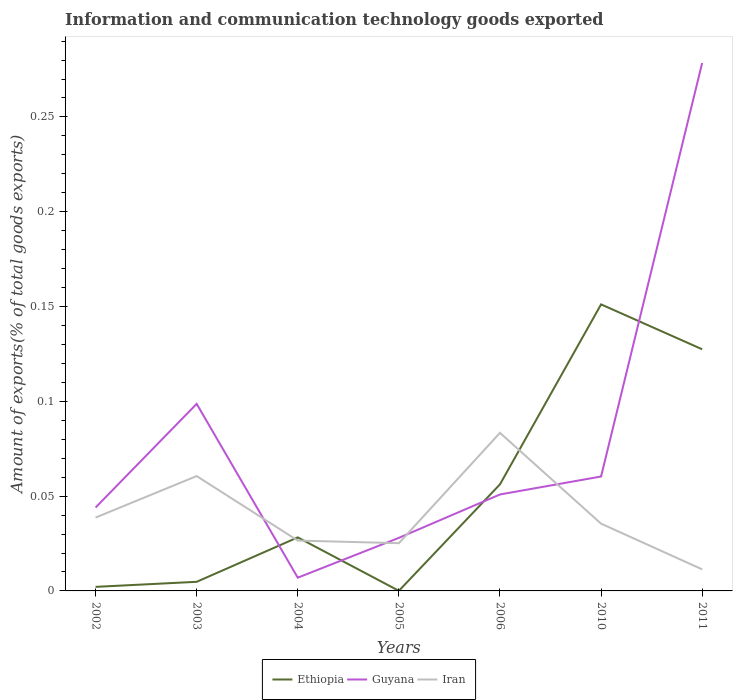Across all years, what is the maximum amount of goods exported in Iran?
Provide a short and direct response. 0.01. In which year was the amount of goods exported in Guyana maximum?
Provide a short and direct response. 2004. What is the total amount of goods exported in Guyana in the graph?
Ensure brevity in your answer.  -0.01. What is the difference between the highest and the second highest amount of goods exported in Ethiopia?
Give a very brief answer. 0.15. What is the difference between the highest and the lowest amount of goods exported in Iran?
Offer a very short reply. 2. Is the amount of goods exported in Ethiopia strictly greater than the amount of goods exported in Iran over the years?
Give a very brief answer. No. How many lines are there?
Offer a very short reply. 3. Does the graph contain any zero values?
Your response must be concise. No. Does the graph contain grids?
Your answer should be very brief. No. How are the legend labels stacked?
Ensure brevity in your answer.  Horizontal. What is the title of the graph?
Give a very brief answer. Information and communication technology goods exported. What is the label or title of the X-axis?
Make the answer very short. Years. What is the label or title of the Y-axis?
Provide a succinct answer. Amount of exports(% of total goods exports). What is the Amount of exports(% of total goods exports) of Ethiopia in 2002?
Offer a very short reply. 0. What is the Amount of exports(% of total goods exports) in Guyana in 2002?
Your answer should be compact. 0.04. What is the Amount of exports(% of total goods exports) of Iran in 2002?
Provide a succinct answer. 0.04. What is the Amount of exports(% of total goods exports) of Ethiopia in 2003?
Your answer should be very brief. 0. What is the Amount of exports(% of total goods exports) in Guyana in 2003?
Ensure brevity in your answer.  0.1. What is the Amount of exports(% of total goods exports) in Iran in 2003?
Offer a terse response. 0.06. What is the Amount of exports(% of total goods exports) in Ethiopia in 2004?
Ensure brevity in your answer.  0.03. What is the Amount of exports(% of total goods exports) of Guyana in 2004?
Offer a terse response. 0.01. What is the Amount of exports(% of total goods exports) in Iran in 2004?
Keep it short and to the point. 0.03. What is the Amount of exports(% of total goods exports) of Ethiopia in 2005?
Keep it short and to the point. 5.79786e-5. What is the Amount of exports(% of total goods exports) of Guyana in 2005?
Your answer should be very brief. 0.03. What is the Amount of exports(% of total goods exports) of Iran in 2005?
Provide a succinct answer. 0.03. What is the Amount of exports(% of total goods exports) of Ethiopia in 2006?
Give a very brief answer. 0.06. What is the Amount of exports(% of total goods exports) of Guyana in 2006?
Your response must be concise. 0.05. What is the Amount of exports(% of total goods exports) in Iran in 2006?
Your answer should be very brief. 0.08. What is the Amount of exports(% of total goods exports) of Ethiopia in 2010?
Make the answer very short. 0.15. What is the Amount of exports(% of total goods exports) of Guyana in 2010?
Provide a short and direct response. 0.06. What is the Amount of exports(% of total goods exports) of Iran in 2010?
Keep it short and to the point. 0.04. What is the Amount of exports(% of total goods exports) of Ethiopia in 2011?
Offer a very short reply. 0.13. What is the Amount of exports(% of total goods exports) in Guyana in 2011?
Keep it short and to the point. 0.28. What is the Amount of exports(% of total goods exports) in Iran in 2011?
Provide a succinct answer. 0.01. Across all years, what is the maximum Amount of exports(% of total goods exports) of Ethiopia?
Offer a terse response. 0.15. Across all years, what is the maximum Amount of exports(% of total goods exports) in Guyana?
Provide a succinct answer. 0.28. Across all years, what is the maximum Amount of exports(% of total goods exports) of Iran?
Your answer should be compact. 0.08. Across all years, what is the minimum Amount of exports(% of total goods exports) of Ethiopia?
Offer a very short reply. 5.79786e-5. Across all years, what is the minimum Amount of exports(% of total goods exports) of Guyana?
Provide a short and direct response. 0.01. Across all years, what is the minimum Amount of exports(% of total goods exports) in Iran?
Offer a very short reply. 0.01. What is the total Amount of exports(% of total goods exports) of Ethiopia in the graph?
Your answer should be compact. 0.37. What is the total Amount of exports(% of total goods exports) in Guyana in the graph?
Offer a very short reply. 0.57. What is the total Amount of exports(% of total goods exports) of Iran in the graph?
Provide a succinct answer. 0.28. What is the difference between the Amount of exports(% of total goods exports) in Ethiopia in 2002 and that in 2003?
Your answer should be very brief. -0. What is the difference between the Amount of exports(% of total goods exports) in Guyana in 2002 and that in 2003?
Offer a terse response. -0.05. What is the difference between the Amount of exports(% of total goods exports) in Iran in 2002 and that in 2003?
Make the answer very short. -0.02. What is the difference between the Amount of exports(% of total goods exports) in Ethiopia in 2002 and that in 2004?
Provide a short and direct response. -0.03. What is the difference between the Amount of exports(% of total goods exports) in Guyana in 2002 and that in 2004?
Your response must be concise. 0.04. What is the difference between the Amount of exports(% of total goods exports) of Iran in 2002 and that in 2004?
Ensure brevity in your answer.  0.01. What is the difference between the Amount of exports(% of total goods exports) of Ethiopia in 2002 and that in 2005?
Offer a very short reply. 0. What is the difference between the Amount of exports(% of total goods exports) in Guyana in 2002 and that in 2005?
Provide a short and direct response. 0.02. What is the difference between the Amount of exports(% of total goods exports) in Iran in 2002 and that in 2005?
Ensure brevity in your answer.  0.01. What is the difference between the Amount of exports(% of total goods exports) in Ethiopia in 2002 and that in 2006?
Make the answer very short. -0.05. What is the difference between the Amount of exports(% of total goods exports) of Guyana in 2002 and that in 2006?
Make the answer very short. -0.01. What is the difference between the Amount of exports(% of total goods exports) of Iran in 2002 and that in 2006?
Keep it short and to the point. -0.04. What is the difference between the Amount of exports(% of total goods exports) in Ethiopia in 2002 and that in 2010?
Your response must be concise. -0.15. What is the difference between the Amount of exports(% of total goods exports) in Guyana in 2002 and that in 2010?
Provide a succinct answer. -0.02. What is the difference between the Amount of exports(% of total goods exports) in Iran in 2002 and that in 2010?
Make the answer very short. 0. What is the difference between the Amount of exports(% of total goods exports) in Ethiopia in 2002 and that in 2011?
Provide a short and direct response. -0.13. What is the difference between the Amount of exports(% of total goods exports) in Guyana in 2002 and that in 2011?
Offer a very short reply. -0.23. What is the difference between the Amount of exports(% of total goods exports) of Iran in 2002 and that in 2011?
Your answer should be compact. 0.03. What is the difference between the Amount of exports(% of total goods exports) in Ethiopia in 2003 and that in 2004?
Provide a short and direct response. -0.02. What is the difference between the Amount of exports(% of total goods exports) in Guyana in 2003 and that in 2004?
Provide a succinct answer. 0.09. What is the difference between the Amount of exports(% of total goods exports) of Iran in 2003 and that in 2004?
Offer a very short reply. 0.03. What is the difference between the Amount of exports(% of total goods exports) of Ethiopia in 2003 and that in 2005?
Offer a very short reply. 0. What is the difference between the Amount of exports(% of total goods exports) of Guyana in 2003 and that in 2005?
Ensure brevity in your answer.  0.07. What is the difference between the Amount of exports(% of total goods exports) of Iran in 2003 and that in 2005?
Make the answer very short. 0.04. What is the difference between the Amount of exports(% of total goods exports) in Ethiopia in 2003 and that in 2006?
Provide a short and direct response. -0.05. What is the difference between the Amount of exports(% of total goods exports) of Guyana in 2003 and that in 2006?
Your answer should be compact. 0.05. What is the difference between the Amount of exports(% of total goods exports) in Iran in 2003 and that in 2006?
Offer a very short reply. -0.02. What is the difference between the Amount of exports(% of total goods exports) in Ethiopia in 2003 and that in 2010?
Provide a succinct answer. -0.15. What is the difference between the Amount of exports(% of total goods exports) in Guyana in 2003 and that in 2010?
Your answer should be compact. 0.04. What is the difference between the Amount of exports(% of total goods exports) in Iran in 2003 and that in 2010?
Ensure brevity in your answer.  0.03. What is the difference between the Amount of exports(% of total goods exports) in Ethiopia in 2003 and that in 2011?
Make the answer very short. -0.12. What is the difference between the Amount of exports(% of total goods exports) of Guyana in 2003 and that in 2011?
Ensure brevity in your answer.  -0.18. What is the difference between the Amount of exports(% of total goods exports) in Iran in 2003 and that in 2011?
Keep it short and to the point. 0.05. What is the difference between the Amount of exports(% of total goods exports) in Ethiopia in 2004 and that in 2005?
Ensure brevity in your answer.  0.03. What is the difference between the Amount of exports(% of total goods exports) in Guyana in 2004 and that in 2005?
Provide a succinct answer. -0.02. What is the difference between the Amount of exports(% of total goods exports) of Iran in 2004 and that in 2005?
Ensure brevity in your answer.  0. What is the difference between the Amount of exports(% of total goods exports) in Ethiopia in 2004 and that in 2006?
Keep it short and to the point. -0.03. What is the difference between the Amount of exports(% of total goods exports) of Guyana in 2004 and that in 2006?
Your answer should be very brief. -0.04. What is the difference between the Amount of exports(% of total goods exports) of Iran in 2004 and that in 2006?
Offer a terse response. -0.06. What is the difference between the Amount of exports(% of total goods exports) in Ethiopia in 2004 and that in 2010?
Make the answer very short. -0.12. What is the difference between the Amount of exports(% of total goods exports) of Guyana in 2004 and that in 2010?
Keep it short and to the point. -0.05. What is the difference between the Amount of exports(% of total goods exports) of Iran in 2004 and that in 2010?
Offer a terse response. -0.01. What is the difference between the Amount of exports(% of total goods exports) in Ethiopia in 2004 and that in 2011?
Your answer should be very brief. -0.1. What is the difference between the Amount of exports(% of total goods exports) in Guyana in 2004 and that in 2011?
Make the answer very short. -0.27. What is the difference between the Amount of exports(% of total goods exports) in Iran in 2004 and that in 2011?
Your response must be concise. 0.02. What is the difference between the Amount of exports(% of total goods exports) of Ethiopia in 2005 and that in 2006?
Ensure brevity in your answer.  -0.06. What is the difference between the Amount of exports(% of total goods exports) of Guyana in 2005 and that in 2006?
Provide a short and direct response. -0.02. What is the difference between the Amount of exports(% of total goods exports) in Iran in 2005 and that in 2006?
Provide a succinct answer. -0.06. What is the difference between the Amount of exports(% of total goods exports) of Ethiopia in 2005 and that in 2010?
Offer a very short reply. -0.15. What is the difference between the Amount of exports(% of total goods exports) of Guyana in 2005 and that in 2010?
Your answer should be compact. -0.03. What is the difference between the Amount of exports(% of total goods exports) of Iran in 2005 and that in 2010?
Offer a terse response. -0.01. What is the difference between the Amount of exports(% of total goods exports) in Ethiopia in 2005 and that in 2011?
Keep it short and to the point. -0.13. What is the difference between the Amount of exports(% of total goods exports) in Guyana in 2005 and that in 2011?
Offer a terse response. -0.25. What is the difference between the Amount of exports(% of total goods exports) of Iran in 2005 and that in 2011?
Give a very brief answer. 0.01. What is the difference between the Amount of exports(% of total goods exports) in Ethiopia in 2006 and that in 2010?
Offer a terse response. -0.09. What is the difference between the Amount of exports(% of total goods exports) in Guyana in 2006 and that in 2010?
Keep it short and to the point. -0.01. What is the difference between the Amount of exports(% of total goods exports) in Iran in 2006 and that in 2010?
Your response must be concise. 0.05. What is the difference between the Amount of exports(% of total goods exports) of Ethiopia in 2006 and that in 2011?
Your answer should be compact. -0.07. What is the difference between the Amount of exports(% of total goods exports) in Guyana in 2006 and that in 2011?
Provide a succinct answer. -0.23. What is the difference between the Amount of exports(% of total goods exports) of Iran in 2006 and that in 2011?
Provide a succinct answer. 0.07. What is the difference between the Amount of exports(% of total goods exports) of Ethiopia in 2010 and that in 2011?
Your answer should be very brief. 0.02. What is the difference between the Amount of exports(% of total goods exports) of Guyana in 2010 and that in 2011?
Your answer should be very brief. -0.22. What is the difference between the Amount of exports(% of total goods exports) of Iran in 2010 and that in 2011?
Make the answer very short. 0.02. What is the difference between the Amount of exports(% of total goods exports) of Ethiopia in 2002 and the Amount of exports(% of total goods exports) of Guyana in 2003?
Keep it short and to the point. -0.1. What is the difference between the Amount of exports(% of total goods exports) in Ethiopia in 2002 and the Amount of exports(% of total goods exports) in Iran in 2003?
Your response must be concise. -0.06. What is the difference between the Amount of exports(% of total goods exports) in Guyana in 2002 and the Amount of exports(% of total goods exports) in Iran in 2003?
Offer a terse response. -0.02. What is the difference between the Amount of exports(% of total goods exports) in Ethiopia in 2002 and the Amount of exports(% of total goods exports) in Guyana in 2004?
Your answer should be very brief. -0. What is the difference between the Amount of exports(% of total goods exports) of Ethiopia in 2002 and the Amount of exports(% of total goods exports) of Iran in 2004?
Offer a terse response. -0.02. What is the difference between the Amount of exports(% of total goods exports) in Guyana in 2002 and the Amount of exports(% of total goods exports) in Iran in 2004?
Your answer should be very brief. 0.02. What is the difference between the Amount of exports(% of total goods exports) in Ethiopia in 2002 and the Amount of exports(% of total goods exports) in Guyana in 2005?
Offer a very short reply. -0.03. What is the difference between the Amount of exports(% of total goods exports) of Ethiopia in 2002 and the Amount of exports(% of total goods exports) of Iran in 2005?
Your response must be concise. -0.02. What is the difference between the Amount of exports(% of total goods exports) of Guyana in 2002 and the Amount of exports(% of total goods exports) of Iran in 2005?
Offer a terse response. 0.02. What is the difference between the Amount of exports(% of total goods exports) in Ethiopia in 2002 and the Amount of exports(% of total goods exports) in Guyana in 2006?
Keep it short and to the point. -0.05. What is the difference between the Amount of exports(% of total goods exports) of Ethiopia in 2002 and the Amount of exports(% of total goods exports) of Iran in 2006?
Ensure brevity in your answer.  -0.08. What is the difference between the Amount of exports(% of total goods exports) in Guyana in 2002 and the Amount of exports(% of total goods exports) in Iran in 2006?
Keep it short and to the point. -0.04. What is the difference between the Amount of exports(% of total goods exports) of Ethiopia in 2002 and the Amount of exports(% of total goods exports) of Guyana in 2010?
Ensure brevity in your answer.  -0.06. What is the difference between the Amount of exports(% of total goods exports) of Ethiopia in 2002 and the Amount of exports(% of total goods exports) of Iran in 2010?
Provide a succinct answer. -0.03. What is the difference between the Amount of exports(% of total goods exports) of Guyana in 2002 and the Amount of exports(% of total goods exports) of Iran in 2010?
Keep it short and to the point. 0.01. What is the difference between the Amount of exports(% of total goods exports) of Ethiopia in 2002 and the Amount of exports(% of total goods exports) of Guyana in 2011?
Ensure brevity in your answer.  -0.28. What is the difference between the Amount of exports(% of total goods exports) in Ethiopia in 2002 and the Amount of exports(% of total goods exports) in Iran in 2011?
Provide a short and direct response. -0.01. What is the difference between the Amount of exports(% of total goods exports) of Guyana in 2002 and the Amount of exports(% of total goods exports) of Iran in 2011?
Your answer should be very brief. 0.03. What is the difference between the Amount of exports(% of total goods exports) of Ethiopia in 2003 and the Amount of exports(% of total goods exports) of Guyana in 2004?
Give a very brief answer. -0. What is the difference between the Amount of exports(% of total goods exports) of Ethiopia in 2003 and the Amount of exports(% of total goods exports) of Iran in 2004?
Your response must be concise. -0.02. What is the difference between the Amount of exports(% of total goods exports) of Guyana in 2003 and the Amount of exports(% of total goods exports) of Iran in 2004?
Provide a succinct answer. 0.07. What is the difference between the Amount of exports(% of total goods exports) in Ethiopia in 2003 and the Amount of exports(% of total goods exports) in Guyana in 2005?
Ensure brevity in your answer.  -0.02. What is the difference between the Amount of exports(% of total goods exports) of Ethiopia in 2003 and the Amount of exports(% of total goods exports) of Iran in 2005?
Your answer should be compact. -0.02. What is the difference between the Amount of exports(% of total goods exports) in Guyana in 2003 and the Amount of exports(% of total goods exports) in Iran in 2005?
Your answer should be very brief. 0.07. What is the difference between the Amount of exports(% of total goods exports) in Ethiopia in 2003 and the Amount of exports(% of total goods exports) in Guyana in 2006?
Offer a terse response. -0.05. What is the difference between the Amount of exports(% of total goods exports) in Ethiopia in 2003 and the Amount of exports(% of total goods exports) in Iran in 2006?
Your answer should be compact. -0.08. What is the difference between the Amount of exports(% of total goods exports) of Guyana in 2003 and the Amount of exports(% of total goods exports) of Iran in 2006?
Offer a terse response. 0.02. What is the difference between the Amount of exports(% of total goods exports) of Ethiopia in 2003 and the Amount of exports(% of total goods exports) of Guyana in 2010?
Offer a very short reply. -0.06. What is the difference between the Amount of exports(% of total goods exports) in Ethiopia in 2003 and the Amount of exports(% of total goods exports) in Iran in 2010?
Give a very brief answer. -0.03. What is the difference between the Amount of exports(% of total goods exports) in Guyana in 2003 and the Amount of exports(% of total goods exports) in Iran in 2010?
Your response must be concise. 0.06. What is the difference between the Amount of exports(% of total goods exports) of Ethiopia in 2003 and the Amount of exports(% of total goods exports) of Guyana in 2011?
Make the answer very short. -0.27. What is the difference between the Amount of exports(% of total goods exports) of Ethiopia in 2003 and the Amount of exports(% of total goods exports) of Iran in 2011?
Offer a very short reply. -0.01. What is the difference between the Amount of exports(% of total goods exports) in Guyana in 2003 and the Amount of exports(% of total goods exports) in Iran in 2011?
Make the answer very short. 0.09. What is the difference between the Amount of exports(% of total goods exports) of Ethiopia in 2004 and the Amount of exports(% of total goods exports) of Guyana in 2005?
Your answer should be compact. 0. What is the difference between the Amount of exports(% of total goods exports) in Ethiopia in 2004 and the Amount of exports(% of total goods exports) in Iran in 2005?
Provide a succinct answer. 0. What is the difference between the Amount of exports(% of total goods exports) of Guyana in 2004 and the Amount of exports(% of total goods exports) of Iran in 2005?
Your answer should be very brief. -0.02. What is the difference between the Amount of exports(% of total goods exports) in Ethiopia in 2004 and the Amount of exports(% of total goods exports) in Guyana in 2006?
Ensure brevity in your answer.  -0.02. What is the difference between the Amount of exports(% of total goods exports) of Ethiopia in 2004 and the Amount of exports(% of total goods exports) of Iran in 2006?
Ensure brevity in your answer.  -0.06. What is the difference between the Amount of exports(% of total goods exports) in Guyana in 2004 and the Amount of exports(% of total goods exports) in Iran in 2006?
Offer a terse response. -0.08. What is the difference between the Amount of exports(% of total goods exports) of Ethiopia in 2004 and the Amount of exports(% of total goods exports) of Guyana in 2010?
Give a very brief answer. -0.03. What is the difference between the Amount of exports(% of total goods exports) of Ethiopia in 2004 and the Amount of exports(% of total goods exports) of Iran in 2010?
Give a very brief answer. -0.01. What is the difference between the Amount of exports(% of total goods exports) in Guyana in 2004 and the Amount of exports(% of total goods exports) in Iran in 2010?
Keep it short and to the point. -0.03. What is the difference between the Amount of exports(% of total goods exports) in Ethiopia in 2004 and the Amount of exports(% of total goods exports) in Guyana in 2011?
Make the answer very short. -0.25. What is the difference between the Amount of exports(% of total goods exports) in Ethiopia in 2004 and the Amount of exports(% of total goods exports) in Iran in 2011?
Your answer should be compact. 0.02. What is the difference between the Amount of exports(% of total goods exports) in Guyana in 2004 and the Amount of exports(% of total goods exports) in Iran in 2011?
Provide a succinct answer. -0. What is the difference between the Amount of exports(% of total goods exports) in Ethiopia in 2005 and the Amount of exports(% of total goods exports) in Guyana in 2006?
Your response must be concise. -0.05. What is the difference between the Amount of exports(% of total goods exports) in Ethiopia in 2005 and the Amount of exports(% of total goods exports) in Iran in 2006?
Keep it short and to the point. -0.08. What is the difference between the Amount of exports(% of total goods exports) in Guyana in 2005 and the Amount of exports(% of total goods exports) in Iran in 2006?
Provide a short and direct response. -0.06. What is the difference between the Amount of exports(% of total goods exports) of Ethiopia in 2005 and the Amount of exports(% of total goods exports) of Guyana in 2010?
Your answer should be very brief. -0.06. What is the difference between the Amount of exports(% of total goods exports) of Ethiopia in 2005 and the Amount of exports(% of total goods exports) of Iran in 2010?
Offer a terse response. -0.04. What is the difference between the Amount of exports(% of total goods exports) of Guyana in 2005 and the Amount of exports(% of total goods exports) of Iran in 2010?
Your answer should be very brief. -0.01. What is the difference between the Amount of exports(% of total goods exports) of Ethiopia in 2005 and the Amount of exports(% of total goods exports) of Guyana in 2011?
Offer a very short reply. -0.28. What is the difference between the Amount of exports(% of total goods exports) in Ethiopia in 2005 and the Amount of exports(% of total goods exports) in Iran in 2011?
Ensure brevity in your answer.  -0.01. What is the difference between the Amount of exports(% of total goods exports) in Guyana in 2005 and the Amount of exports(% of total goods exports) in Iran in 2011?
Provide a short and direct response. 0.02. What is the difference between the Amount of exports(% of total goods exports) of Ethiopia in 2006 and the Amount of exports(% of total goods exports) of Guyana in 2010?
Provide a short and direct response. -0. What is the difference between the Amount of exports(% of total goods exports) of Ethiopia in 2006 and the Amount of exports(% of total goods exports) of Iran in 2010?
Offer a terse response. 0.02. What is the difference between the Amount of exports(% of total goods exports) of Guyana in 2006 and the Amount of exports(% of total goods exports) of Iran in 2010?
Make the answer very short. 0.02. What is the difference between the Amount of exports(% of total goods exports) of Ethiopia in 2006 and the Amount of exports(% of total goods exports) of Guyana in 2011?
Your answer should be compact. -0.22. What is the difference between the Amount of exports(% of total goods exports) of Ethiopia in 2006 and the Amount of exports(% of total goods exports) of Iran in 2011?
Ensure brevity in your answer.  0.04. What is the difference between the Amount of exports(% of total goods exports) of Guyana in 2006 and the Amount of exports(% of total goods exports) of Iran in 2011?
Your response must be concise. 0.04. What is the difference between the Amount of exports(% of total goods exports) in Ethiopia in 2010 and the Amount of exports(% of total goods exports) in Guyana in 2011?
Ensure brevity in your answer.  -0.13. What is the difference between the Amount of exports(% of total goods exports) of Ethiopia in 2010 and the Amount of exports(% of total goods exports) of Iran in 2011?
Provide a succinct answer. 0.14. What is the difference between the Amount of exports(% of total goods exports) of Guyana in 2010 and the Amount of exports(% of total goods exports) of Iran in 2011?
Offer a very short reply. 0.05. What is the average Amount of exports(% of total goods exports) of Ethiopia per year?
Your response must be concise. 0.05. What is the average Amount of exports(% of total goods exports) in Guyana per year?
Make the answer very short. 0.08. What is the average Amount of exports(% of total goods exports) in Iran per year?
Make the answer very short. 0.04. In the year 2002, what is the difference between the Amount of exports(% of total goods exports) of Ethiopia and Amount of exports(% of total goods exports) of Guyana?
Provide a short and direct response. -0.04. In the year 2002, what is the difference between the Amount of exports(% of total goods exports) of Ethiopia and Amount of exports(% of total goods exports) of Iran?
Give a very brief answer. -0.04. In the year 2002, what is the difference between the Amount of exports(% of total goods exports) in Guyana and Amount of exports(% of total goods exports) in Iran?
Provide a short and direct response. 0.01. In the year 2003, what is the difference between the Amount of exports(% of total goods exports) of Ethiopia and Amount of exports(% of total goods exports) of Guyana?
Give a very brief answer. -0.09. In the year 2003, what is the difference between the Amount of exports(% of total goods exports) of Ethiopia and Amount of exports(% of total goods exports) of Iran?
Provide a succinct answer. -0.06. In the year 2003, what is the difference between the Amount of exports(% of total goods exports) in Guyana and Amount of exports(% of total goods exports) in Iran?
Ensure brevity in your answer.  0.04. In the year 2004, what is the difference between the Amount of exports(% of total goods exports) in Ethiopia and Amount of exports(% of total goods exports) in Guyana?
Your answer should be compact. 0.02. In the year 2004, what is the difference between the Amount of exports(% of total goods exports) of Ethiopia and Amount of exports(% of total goods exports) of Iran?
Ensure brevity in your answer.  0. In the year 2004, what is the difference between the Amount of exports(% of total goods exports) in Guyana and Amount of exports(% of total goods exports) in Iran?
Ensure brevity in your answer.  -0.02. In the year 2005, what is the difference between the Amount of exports(% of total goods exports) in Ethiopia and Amount of exports(% of total goods exports) in Guyana?
Your answer should be very brief. -0.03. In the year 2005, what is the difference between the Amount of exports(% of total goods exports) in Ethiopia and Amount of exports(% of total goods exports) in Iran?
Keep it short and to the point. -0.03. In the year 2005, what is the difference between the Amount of exports(% of total goods exports) of Guyana and Amount of exports(% of total goods exports) of Iran?
Your answer should be compact. 0. In the year 2006, what is the difference between the Amount of exports(% of total goods exports) of Ethiopia and Amount of exports(% of total goods exports) of Guyana?
Give a very brief answer. 0.01. In the year 2006, what is the difference between the Amount of exports(% of total goods exports) of Ethiopia and Amount of exports(% of total goods exports) of Iran?
Your answer should be very brief. -0.03. In the year 2006, what is the difference between the Amount of exports(% of total goods exports) in Guyana and Amount of exports(% of total goods exports) in Iran?
Offer a very short reply. -0.03. In the year 2010, what is the difference between the Amount of exports(% of total goods exports) of Ethiopia and Amount of exports(% of total goods exports) of Guyana?
Provide a succinct answer. 0.09. In the year 2010, what is the difference between the Amount of exports(% of total goods exports) of Ethiopia and Amount of exports(% of total goods exports) of Iran?
Provide a short and direct response. 0.12. In the year 2010, what is the difference between the Amount of exports(% of total goods exports) of Guyana and Amount of exports(% of total goods exports) of Iran?
Give a very brief answer. 0.02. In the year 2011, what is the difference between the Amount of exports(% of total goods exports) of Ethiopia and Amount of exports(% of total goods exports) of Guyana?
Offer a terse response. -0.15. In the year 2011, what is the difference between the Amount of exports(% of total goods exports) of Ethiopia and Amount of exports(% of total goods exports) of Iran?
Your response must be concise. 0.12. In the year 2011, what is the difference between the Amount of exports(% of total goods exports) in Guyana and Amount of exports(% of total goods exports) in Iran?
Provide a short and direct response. 0.27. What is the ratio of the Amount of exports(% of total goods exports) in Ethiopia in 2002 to that in 2003?
Keep it short and to the point. 0.45. What is the ratio of the Amount of exports(% of total goods exports) in Guyana in 2002 to that in 2003?
Your answer should be very brief. 0.45. What is the ratio of the Amount of exports(% of total goods exports) in Iran in 2002 to that in 2003?
Provide a succinct answer. 0.64. What is the ratio of the Amount of exports(% of total goods exports) in Ethiopia in 2002 to that in 2004?
Make the answer very short. 0.08. What is the ratio of the Amount of exports(% of total goods exports) of Guyana in 2002 to that in 2004?
Ensure brevity in your answer.  6.3. What is the ratio of the Amount of exports(% of total goods exports) of Iran in 2002 to that in 2004?
Offer a very short reply. 1.46. What is the ratio of the Amount of exports(% of total goods exports) of Ethiopia in 2002 to that in 2005?
Keep it short and to the point. 36.96. What is the ratio of the Amount of exports(% of total goods exports) of Guyana in 2002 to that in 2005?
Offer a terse response. 1.57. What is the ratio of the Amount of exports(% of total goods exports) of Iran in 2002 to that in 2005?
Your response must be concise. 1.54. What is the ratio of the Amount of exports(% of total goods exports) in Ethiopia in 2002 to that in 2006?
Provide a succinct answer. 0.04. What is the ratio of the Amount of exports(% of total goods exports) in Guyana in 2002 to that in 2006?
Make the answer very short. 0.86. What is the ratio of the Amount of exports(% of total goods exports) of Iran in 2002 to that in 2006?
Offer a terse response. 0.46. What is the ratio of the Amount of exports(% of total goods exports) of Ethiopia in 2002 to that in 2010?
Your response must be concise. 0.01. What is the ratio of the Amount of exports(% of total goods exports) of Guyana in 2002 to that in 2010?
Give a very brief answer. 0.73. What is the ratio of the Amount of exports(% of total goods exports) of Iran in 2002 to that in 2010?
Make the answer very short. 1.09. What is the ratio of the Amount of exports(% of total goods exports) of Ethiopia in 2002 to that in 2011?
Ensure brevity in your answer.  0.02. What is the ratio of the Amount of exports(% of total goods exports) of Guyana in 2002 to that in 2011?
Offer a very short reply. 0.16. What is the ratio of the Amount of exports(% of total goods exports) of Iran in 2002 to that in 2011?
Keep it short and to the point. 3.4. What is the ratio of the Amount of exports(% of total goods exports) of Ethiopia in 2003 to that in 2004?
Your answer should be very brief. 0.17. What is the ratio of the Amount of exports(% of total goods exports) of Guyana in 2003 to that in 2004?
Provide a succinct answer. 14.12. What is the ratio of the Amount of exports(% of total goods exports) in Iran in 2003 to that in 2004?
Your response must be concise. 2.28. What is the ratio of the Amount of exports(% of total goods exports) in Ethiopia in 2003 to that in 2005?
Make the answer very short. 82.87. What is the ratio of the Amount of exports(% of total goods exports) of Guyana in 2003 to that in 2005?
Your answer should be very brief. 3.53. What is the ratio of the Amount of exports(% of total goods exports) in Iran in 2003 to that in 2005?
Provide a succinct answer. 2.41. What is the ratio of the Amount of exports(% of total goods exports) of Ethiopia in 2003 to that in 2006?
Provide a short and direct response. 0.09. What is the ratio of the Amount of exports(% of total goods exports) of Guyana in 2003 to that in 2006?
Ensure brevity in your answer.  1.94. What is the ratio of the Amount of exports(% of total goods exports) of Iran in 2003 to that in 2006?
Provide a succinct answer. 0.73. What is the ratio of the Amount of exports(% of total goods exports) of Ethiopia in 2003 to that in 2010?
Offer a terse response. 0.03. What is the ratio of the Amount of exports(% of total goods exports) of Guyana in 2003 to that in 2010?
Ensure brevity in your answer.  1.63. What is the ratio of the Amount of exports(% of total goods exports) in Iran in 2003 to that in 2010?
Your answer should be compact. 1.71. What is the ratio of the Amount of exports(% of total goods exports) of Ethiopia in 2003 to that in 2011?
Your answer should be compact. 0.04. What is the ratio of the Amount of exports(% of total goods exports) of Guyana in 2003 to that in 2011?
Your answer should be very brief. 0.35. What is the ratio of the Amount of exports(% of total goods exports) of Iran in 2003 to that in 2011?
Give a very brief answer. 5.32. What is the ratio of the Amount of exports(% of total goods exports) in Ethiopia in 2004 to that in 2005?
Keep it short and to the point. 487.03. What is the ratio of the Amount of exports(% of total goods exports) in Guyana in 2004 to that in 2005?
Your answer should be compact. 0.25. What is the ratio of the Amount of exports(% of total goods exports) in Iran in 2004 to that in 2005?
Give a very brief answer. 1.05. What is the ratio of the Amount of exports(% of total goods exports) in Ethiopia in 2004 to that in 2006?
Your answer should be compact. 0.5. What is the ratio of the Amount of exports(% of total goods exports) of Guyana in 2004 to that in 2006?
Ensure brevity in your answer.  0.14. What is the ratio of the Amount of exports(% of total goods exports) of Iran in 2004 to that in 2006?
Provide a short and direct response. 0.32. What is the ratio of the Amount of exports(% of total goods exports) of Ethiopia in 2004 to that in 2010?
Your answer should be compact. 0.19. What is the ratio of the Amount of exports(% of total goods exports) of Guyana in 2004 to that in 2010?
Keep it short and to the point. 0.12. What is the ratio of the Amount of exports(% of total goods exports) of Iran in 2004 to that in 2010?
Give a very brief answer. 0.75. What is the ratio of the Amount of exports(% of total goods exports) in Ethiopia in 2004 to that in 2011?
Make the answer very short. 0.22. What is the ratio of the Amount of exports(% of total goods exports) of Guyana in 2004 to that in 2011?
Offer a very short reply. 0.03. What is the ratio of the Amount of exports(% of total goods exports) in Iran in 2004 to that in 2011?
Your answer should be very brief. 2.33. What is the ratio of the Amount of exports(% of total goods exports) of Ethiopia in 2005 to that in 2006?
Offer a very short reply. 0. What is the ratio of the Amount of exports(% of total goods exports) in Guyana in 2005 to that in 2006?
Keep it short and to the point. 0.55. What is the ratio of the Amount of exports(% of total goods exports) of Iran in 2005 to that in 2006?
Your answer should be very brief. 0.3. What is the ratio of the Amount of exports(% of total goods exports) in Guyana in 2005 to that in 2010?
Keep it short and to the point. 0.46. What is the ratio of the Amount of exports(% of total goods exports) of Iran in 2005 to that in 2010?
Ensure brevity in your answer.  0.71. What is the ratio of the Amount of exports(% of total goods exports) in Ethiopia in 2005 to that in 2011?
Ensure brevity in your answer.  0. What is the ratio of the Amount of exports(% of total goods exports) of Guyana in 2005 to that in 2011?
Give a very brief answer. 0.1. What is the ratio of the Amount of exports(% of total goods exports) of Iran in 2005 to that in 2011?
Your response must be concise. 2.21. What is the ratio of the Amount of exports(% of total goods exports) of Ethiopia in 2006 to that in 2010?
Your answer should be compact. 0.37. What is the ratio of the Amount of exports(% of total goods exports) of Guyana in 2006 to that in 2010?
Keep it short and to the point. 0.84. What is the ratio of the Amount of exports(% of total goods exports) in Iran in 2006 to that in 2010?
Your answer should be very brief. 2.35. What is the ratio of the Amount of exports(% of total goods exports) in Ethiopia in 2006 to that in 2011?
Keep it short and to the point. 0.44. What is the ratio of the Amount of exports(% of total goods exports) of Guyana in 2006 to that in 2011?
Ensure brevity in your answer.  0.18. What is the ratio of the Amount of exports(% of total goods exports) in Iran in 2006 to that in 2011?
Ensure brevity in your answer.  7.33. What is the ratio of the Amount of exports(% of total goods exports) of Ethiopia in 2010 to that in 2011?
Provide a short and direct response. 1.19. What is the ratio of the Amount of exports(% of total goods exports) in Guyana in 2010 to that in 2011?
Your answer should be compact. 0.22. What is the ratio of the Amount of exports(% of total goods exports) of Iran in 2010 to that in 2011?
Your answer should be very brief. 3.12. What is the difference between the highest and the second highest Amount of exports(% of total goods exports) in Ethiopia?
Offer a terse response. 0.02. What is the difference between the highest and the second highest Amount of exports(% of total goods exports) of Guyana?
Your response must be concise. 0.18. What is the difference between the highest and the second highest Amount of exports(% of total goods exports) of Iran?
Give a very brief answer. 0.02. What is the difference between the highest and the lowest Amount of exports(% of total goods exports) in Ethiopia?
Ensure brevity in your answer.  0.15. What is the difference between the highest and the lowest Amount of exports(% of total goods exports) of Guyana?
Provide a succinct answer. 0.27. What is the difference between the highest and the lowest Amount of exports(% of total goods exports) of Iran?
Offer a terse response. 0.07. 